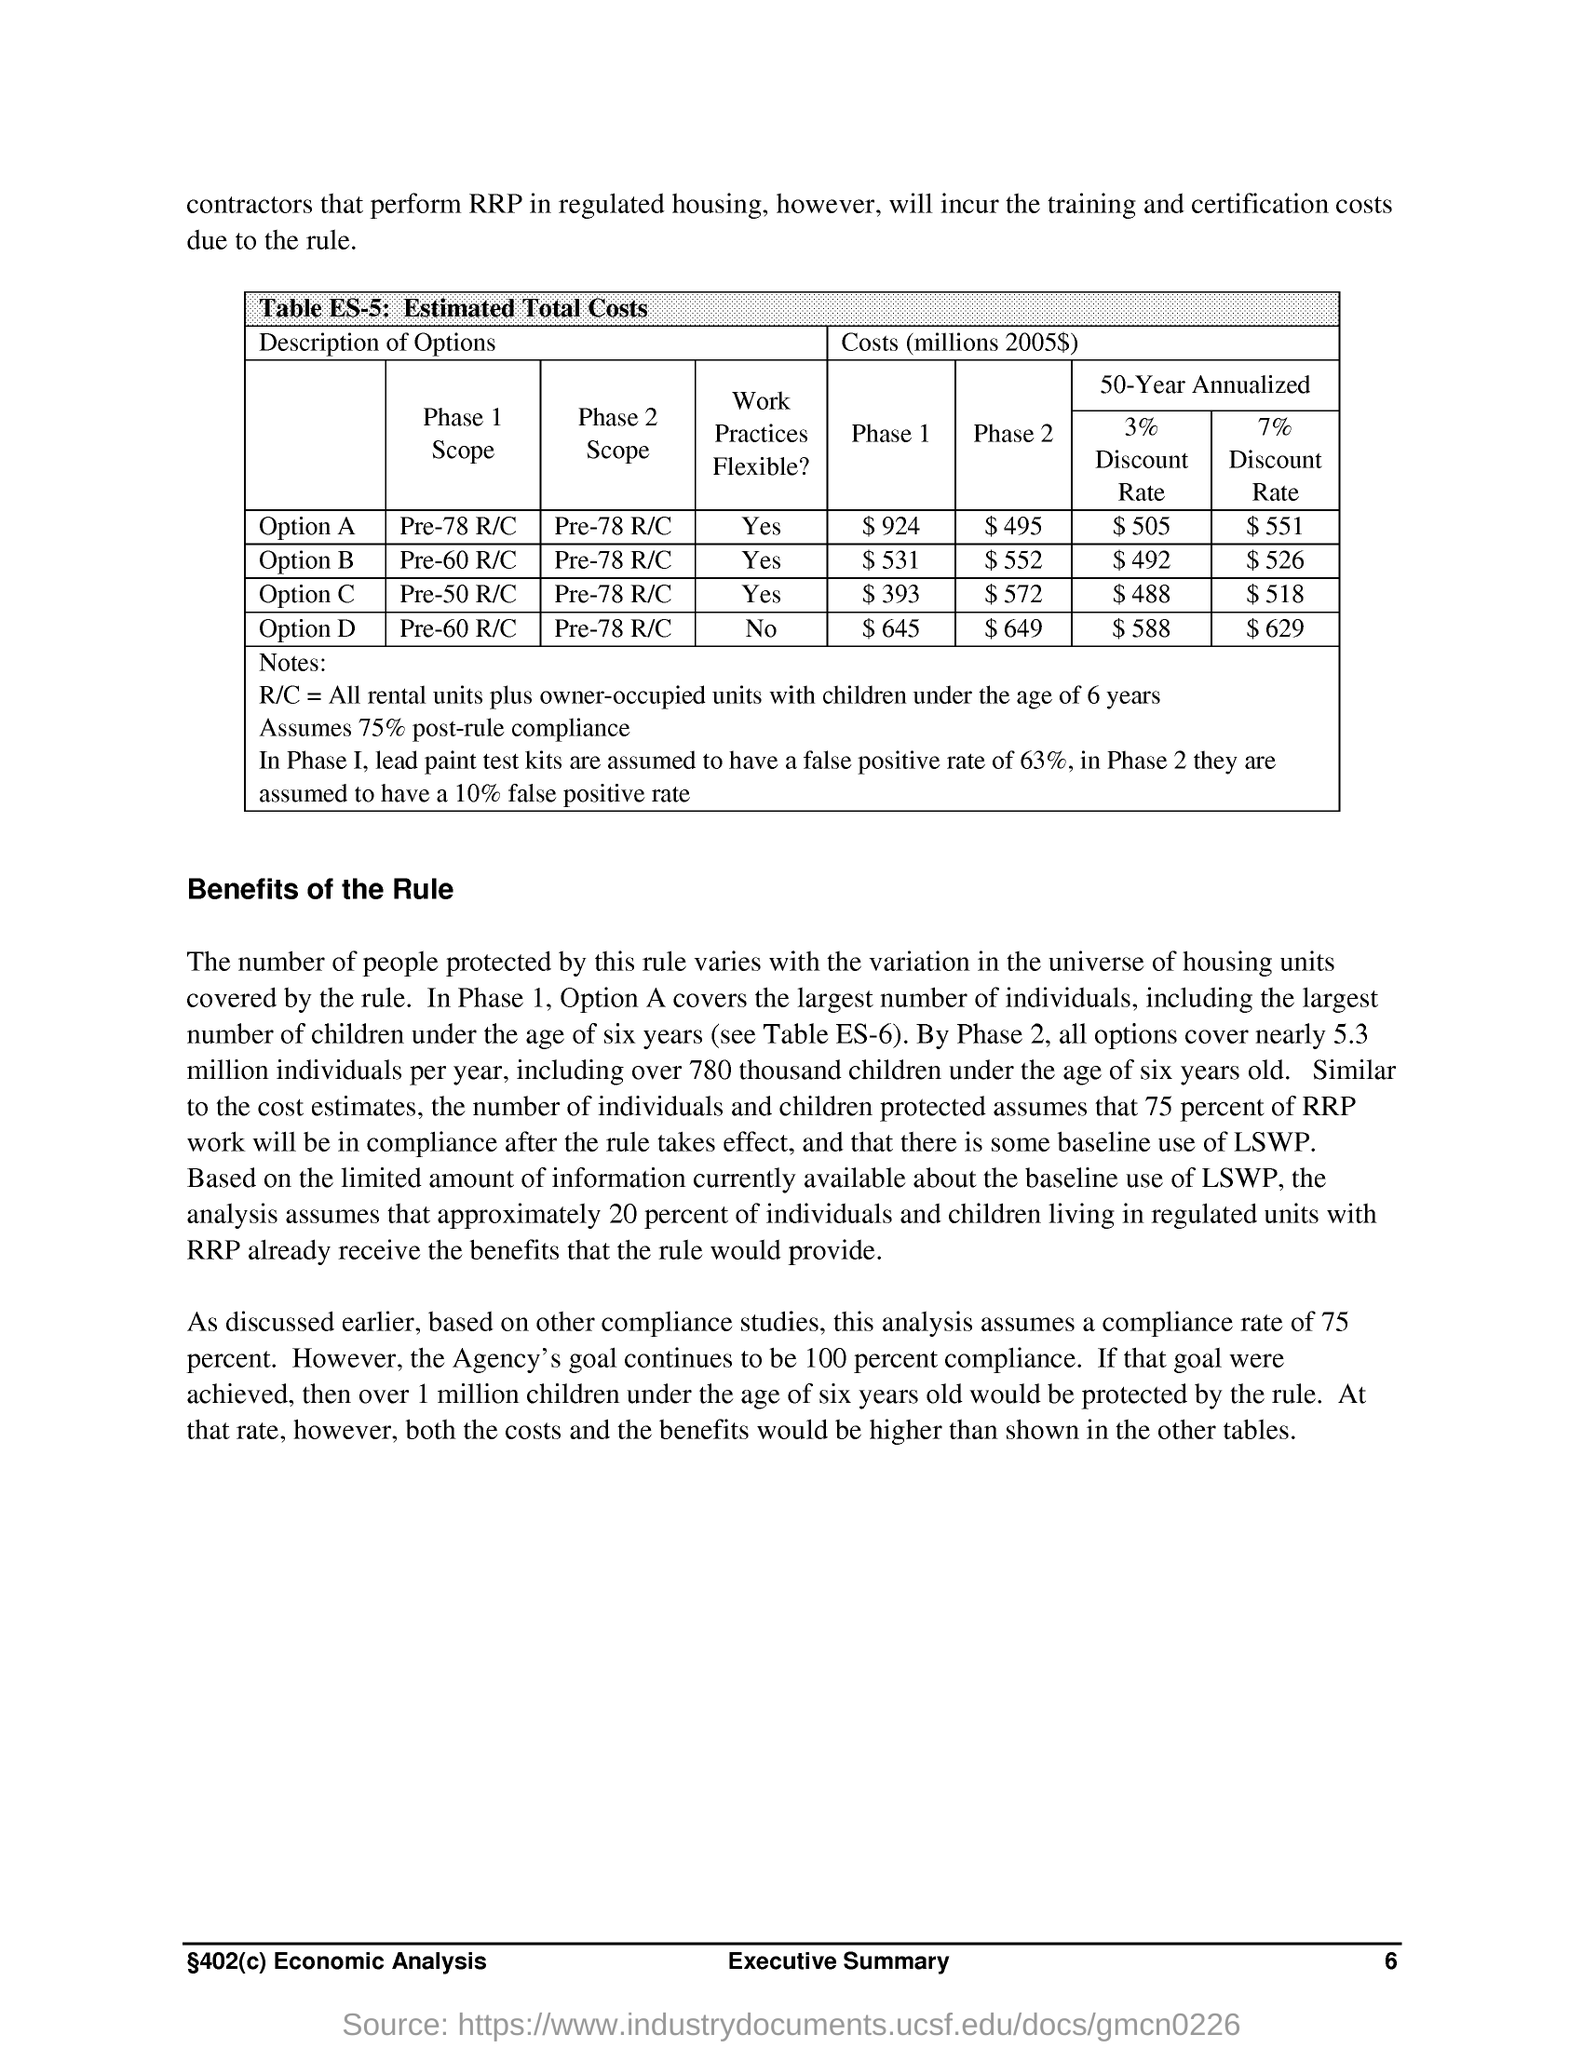What is the assumed compliance rate by this analysis?
Give a very brief answer. 75% POST-RULE COMPLIANCE. 